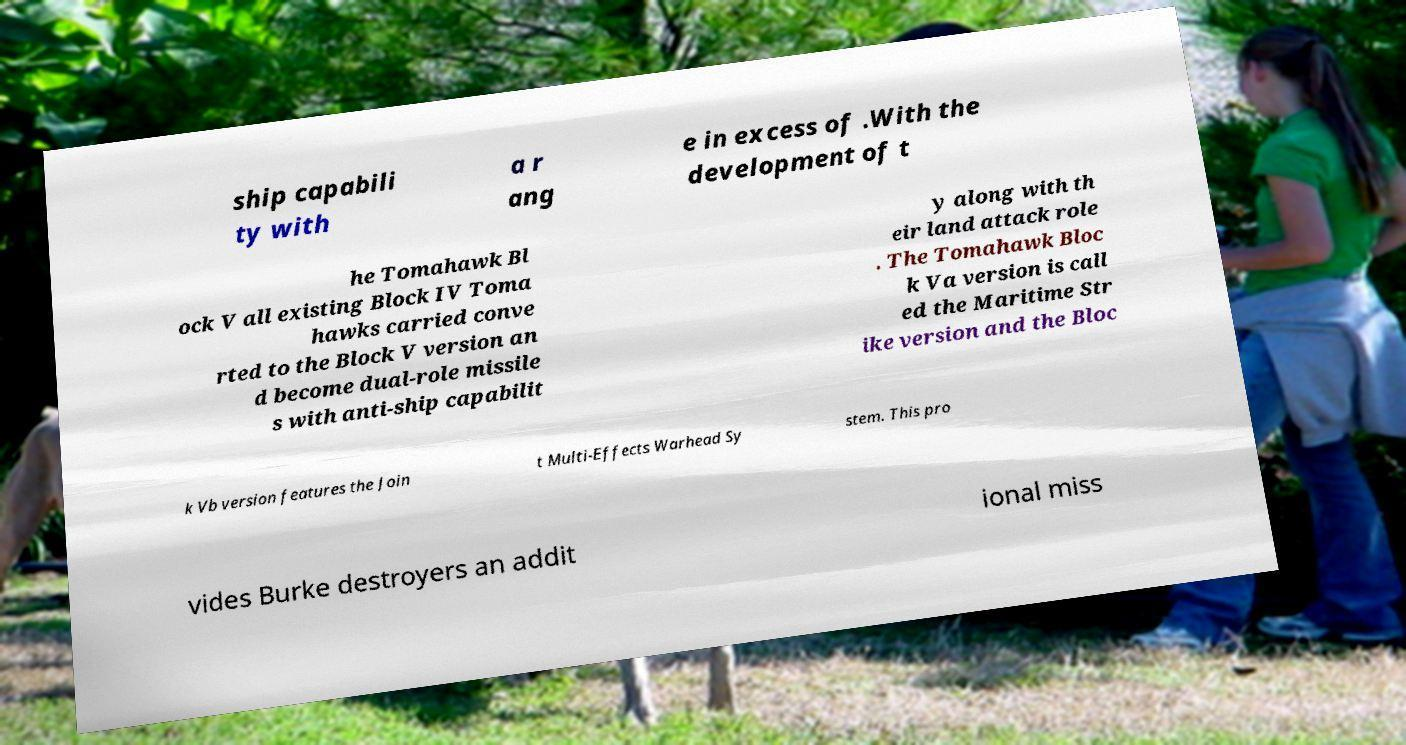Could you extract and type out the text from this image? ship capabili ty with a r ang e in excess of .With the development of t he Tomahawk Bl ock V all existing Block IV Toma hawks carried conve rted to the Block V version an d become dual-role missile s with anti-ship capabilit y along with th eir land attack role . The Tomahawk Bloc k Va version is call ed the Maritime Str ike version and the Bloc k Vb version features the Join t Multi-Effects Warhead Sy stem. This pro vides Burke destroyers an addit ional miss 